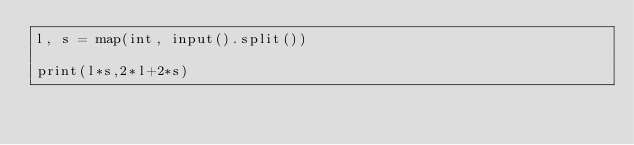Convert code to text. <code><loc_0><loc_0><loc_500><loc_500><_Python_>l, s = map(int, input().split())

print(l*s,2*l+2*s)
</code> 